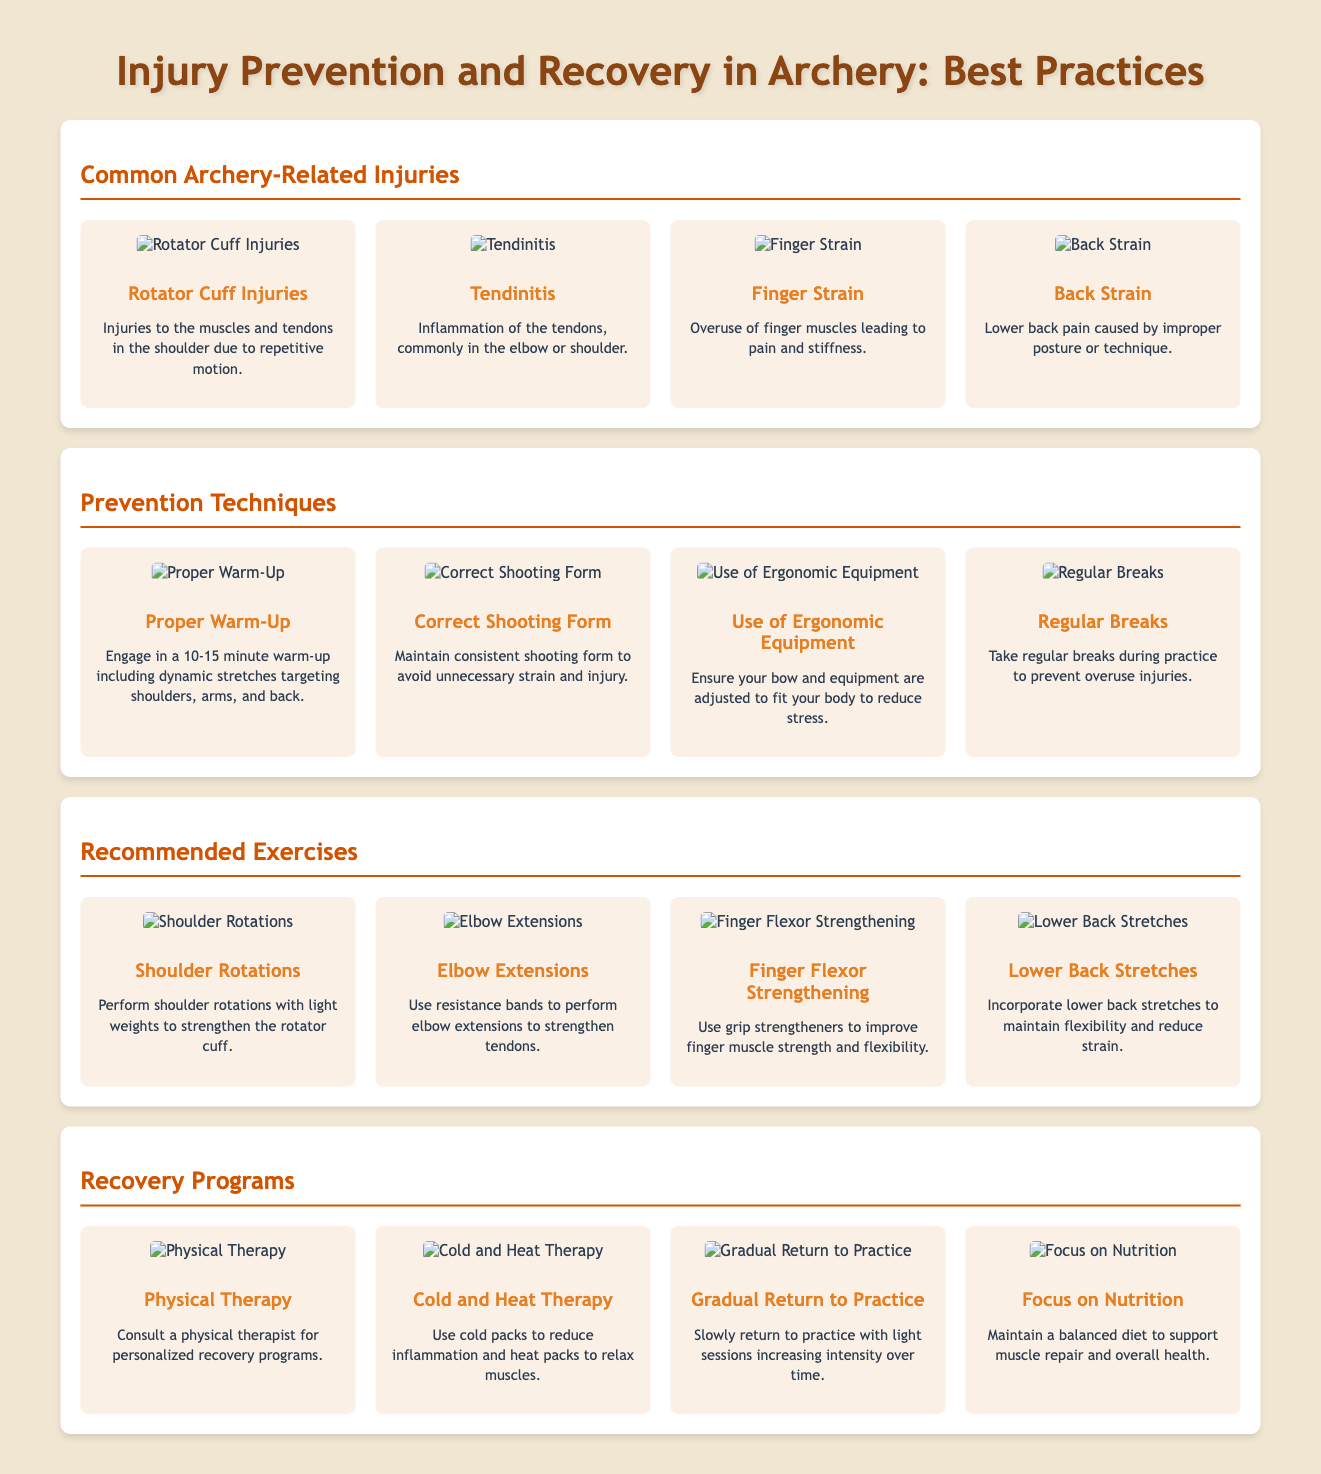What are common archery-related injuries? Common archery-related injuries include Rotator Cuff Injuries, Tendinitis, Finger Strain, and Back Strain as listed in the document.
Answer: Rotator Cuff Injuries, Tendinitis, Finger Strain, Back Strain What should you engage in before practicing archery? The document states that you should engage in a 10-15 minute warm-up including dynamic stretches targeting shoulders, arms, and back.
Answer: Proper Warm-Up Which exercise is recommended for finger strength? The document mentions using grip strengtheners to improve finger muscle strength and flexibility.
Answer: Finger Flexor Strengthening What is one method of therapy mentioned for recovery? The document specifies consulting a physical therapist for personalized recovery programs as a recovery method.
Answer: Physical Therapy How should a return to practice be approached after an injury? According to the guide, a gradual return should be followed, starting with light sessions and increasing intensity over time.
Answer: Gradual Return to Practice 